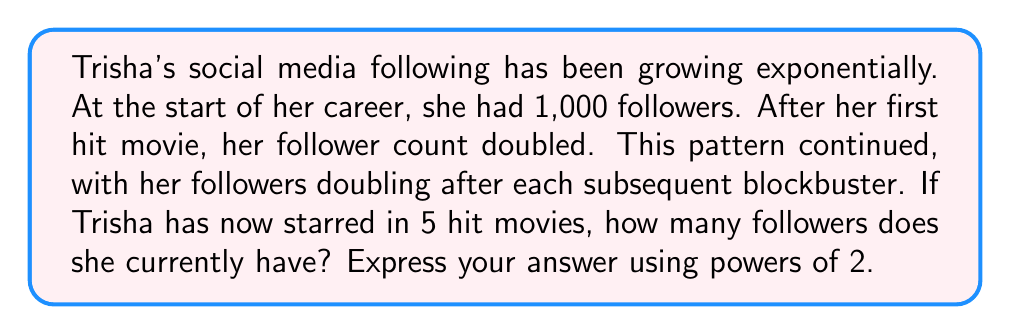Help me with this question. Let's approach this step-by-step using a geometric sequence:

1) The initial number of followers: $a_1 = 1,000$

2) The common ratio: $r = 2$ (as the number of followers doubles each time)

3) The number of terms: $n = 6$ (initial count plus 5 movies)

4) The formula for the nth term of a geometric sequence is:
   $a_n = a_1 \cdot r^{n-1}$

5) Substituting our values:
   $a_6 = 1,000 \cdot 2^{6-1} = 1,000 \cdot 2^5$

6) Simplify:
   $a_6 = 1,000 \cdot 32 = 32,000$

7) Express in powers of 2:
   $32,000 = 1,000 \cdot 2^5 = (1,000 \cdot 2^5)$

Therefore, Trisha's current follower count is $(1,000 \cdot 2^5)$.
Answer: $(1,000 \cdot 2^5)$ followers 